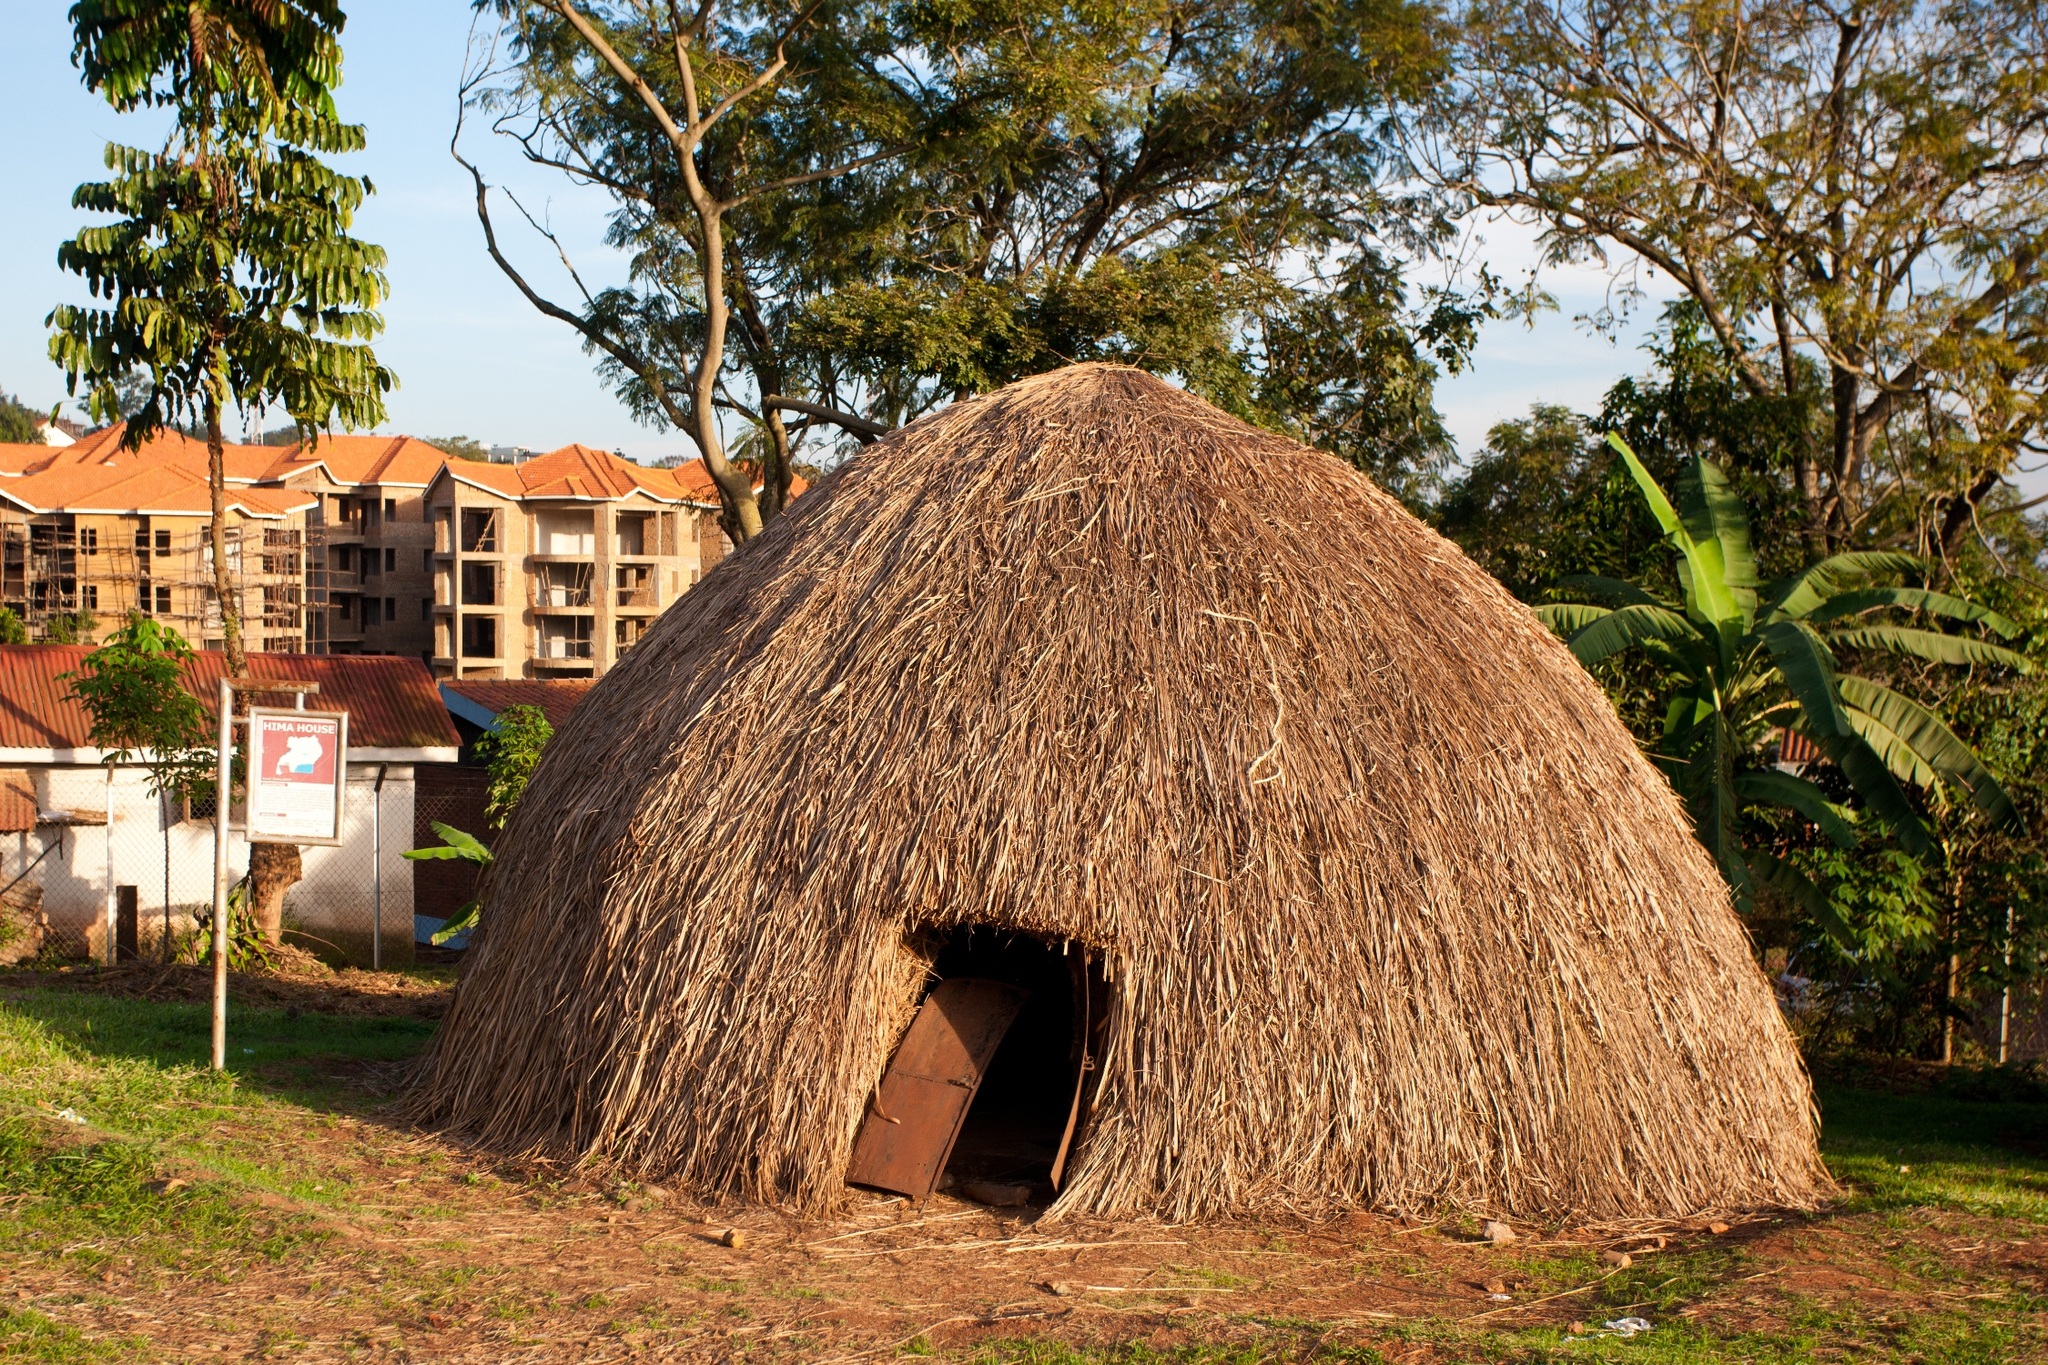How does this hut represent the culture of the area it is located in? The traditional thatched hut is a representation of indigenous architectural techniques adapted to local climates and materials. The use of grasses suggests an abundance of such natural resources in the area. It reflects the practical and sustainable living methods of the community, passed down through generations. The simplicity of the structure emphasizes functionality and the importance of natural elements in construction, which is characteristic of many African societies. 